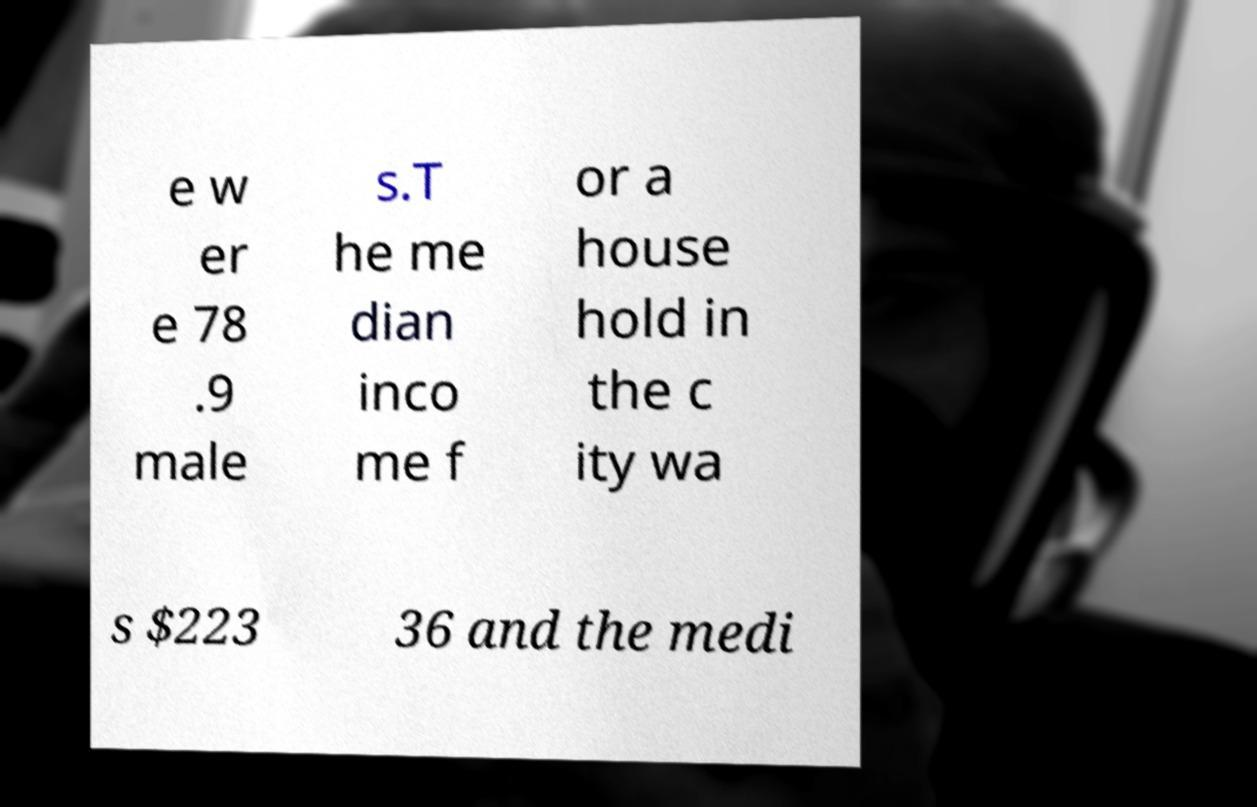Can you accurately transcribe the text from the provided image for me? e w er e 78 .9 male s.T he me dian inco me f or a house hold in the c ity wa s $223 36 and the medi 